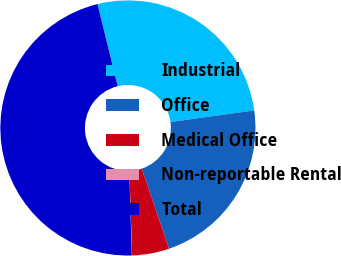Convert chart to OTSL. <chart><loc_0><loc_0><loc_500><loc_500><pie_chart><fcel>Industrial<fcel>Office<fcel>Medical Office<fcel>Non-reportable Rental<fcel>Total<nl><fcel>26.63%<fcel>21.97%<fcel>4.7%<fcel>0.04%<fcel>46.65%<nl></chart> 